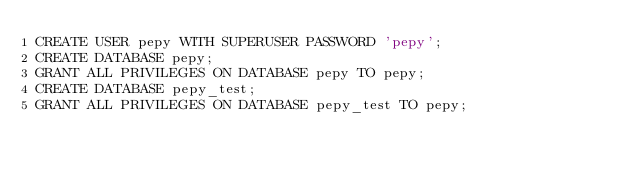Convert code to text. <code><loc_0><loc_0><loc_500><loc_500><_SQL_>CREATE USER pepy WITH SUPERUSER PASSWORD 'pepy';
CREATE DATABASE pepy;
GRANT ALL PRIVILEGES ON DATABASE pepy TO pepy;
CREATE DATABASE pepy_test;
GRANT ALL PRIVILEGES ON DATABASE pepy_test TO pepy;
</code> 